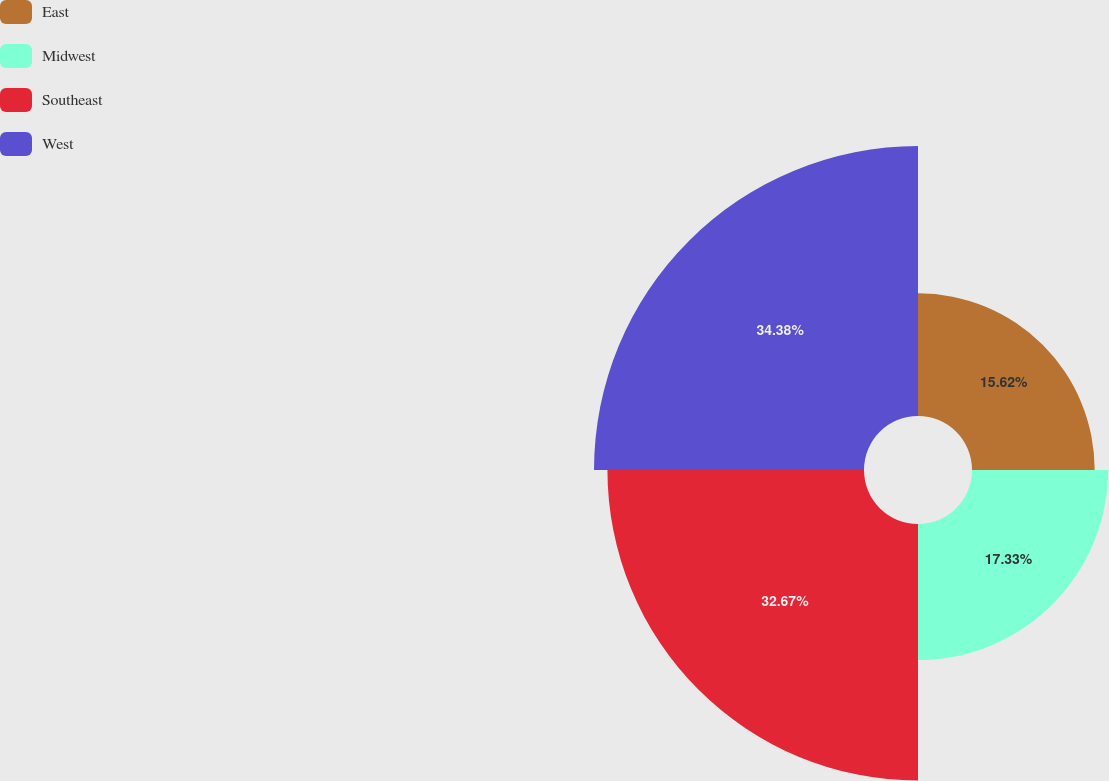<chart> <loc_0><loc_0><loc_500><loc_500><pie_chart><fcel>East<fcel>Midwest<fcel>Southeast<fcel>West<nl><fcel>15.62%<fcel>17.33%<fcel>32.67%<fcel>34.38%<nl></chart> 